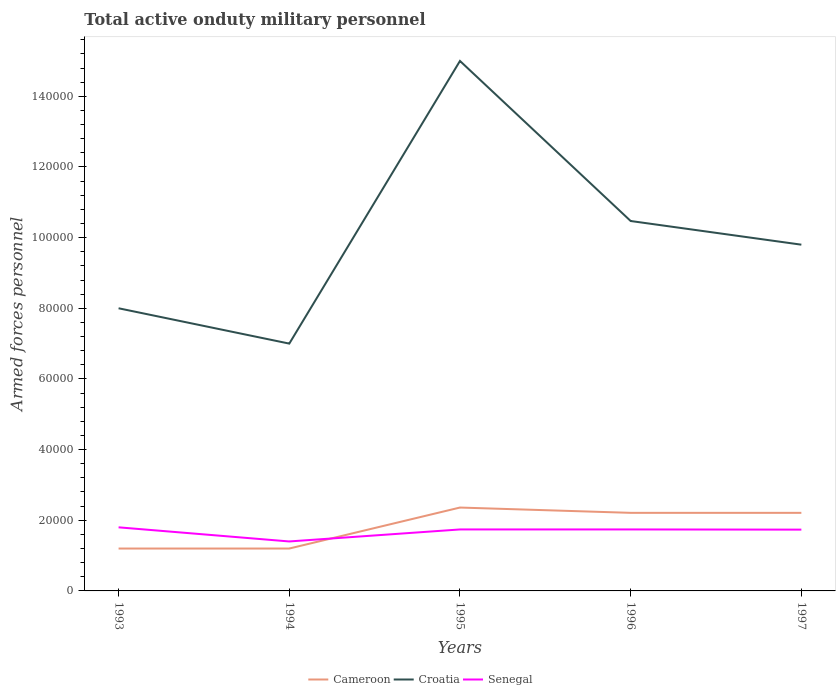How many different coloured lines are there?
Make the answer very short. 3. What is the total number of armed forces personnel in Senegal in the graph?
Provide a short and direct response. 600. What is the difference between the highest and the lowest number of armed forces personnel in Cameroon?
Keep it short and to the point. 3. How many lines are there?
Make the answer very short. 3. What is the difference between two consecutive major ticks on the Y-axis?
Offer a very short reply. 2.00e+04. Does the graph contain any zero values?
Keep it short and to the point. No. Does the graph contain grids?
Your answer should be very brief. No. How are the legend labels stacked?
Provide a short and direct response. Horizontal. What is the title of the graph?
Give a very brief answer. Total active onduty military personnel. What is the label or title of the Y-axis?
Provide a short and direct response. Armed forces personnel. What is the Armed forces personnel in Cameroon in 1993?
Ensure brevity in your answer.  1.20e+04. What is the Armed forces personnel of Senegal in 1993?
Give a very brief answer. 1.80e+04. What is the Armed forces personnel of Cameroon in 1994?
Offer a very short reply. 1.20e+04. What is the Armed forces personnel in Croatia in 1994?
Provide a succinct answer. 7.00e+04. What is the Armed forces personnel of Senegal in 1994?
Your answer should be compact. 1.40e+04. What is the Armed forces personnel of Cameroon in 1995?
Give a very brief answer. 2.36e+04. What is the Armed forces personnel of Senegal in 1995?
Offer a terse response. 1.74e+04. What is the Armed forces personnel of Cameroon in 1996?
Keep it short and to the point. 2.21e+04. What is the Armed forces personnel of Croatia in 1996?
Your answer should be very brief. 1.05e+05. What is the Armed forces personnel of Senegal in 1996?
Your response must be concise. 1.74e+04. What is the Armed forces personnel of Cameroon in 1997?
Provide a short and direct response. 2.21e+04. What is the Armed forces personnel in Croatia in 1997?
Make the answer very short. 9.80e+04. What is the Armed forces personnel of Senegal in 1997?
Offer a very short reply. 1.74e+04. Across all years, what is the maximum Armed forces personnel of Cameroon?
Ensure brevity in your answer.  2.36e+04. Across all years, what is the maximum Armed forces personnel of Croatia?
Your response must be concise. 1.50e+05. Across all years, what is the maximum Armed forces personnel of Senegal?
Your answer should be compact. 1.80e+04. Across all years, what is the minimum Armed forces personnel of Cameroon?
Your answer should be compact. 1.20e+04. Across all years, what is the minimum Armed forces personnel of Croatia?
Your answer should be very brief. 7.00e+04. Across all years, what is the minimum Armed forces personnel of Senegal?
Give a very brief answer. 1.40e+04. What is the total Armed forces personnel in Cameroon in the graph?
Your response must be concise. 9.18e+04. What is the total Armed forces personnel of Croatia in the graph?
Offer a very short reply. 5.03e+05. What is the total Armed forces personnel in Senegal in the graph?
Provide a succinct answer. 8.42e+04. What is the difference between the Armed forces personnel of Cameroon in 1993 and that in 1994?
Ensure brevity in your answer.  0. What is the difference between the Armed forces personnel in Croatia in 1993 and that in 1994?
Give a very brief answer. 10000. What is the difference between the Armed forces personnel in Senegal in 1993 and that in 1994?
Provide a succinct answer. 4000. What is the difference between the Armed forces personnel of Cameroon in 1993 and that in 1995?
Make the answer very short. -1.16e+04. What is the difference between the Armed forces personnel of Croatia in 1993 and that in 1995?
Keep it short and to the point. -7.00e+04. What is the difference between the Armed forces personnel in Senegal in 1993 and that in 1995?
Provide a succinct answer. 600. What is the difference between the Armed forces personnel of Cameroon in 1993 and that in 1996?
Provide a short and direct response. -1.01e+04. What is the difference between the Armed forces personnel in Croatia in 1993 and that in 1996?
Make the answer very short. -2.47e+04. What is the difference between the Armed forces personnel in Senegal in 1993 and that in 1996?
Your response must be concise. 600. What is the difference between the Armed forces personnel of Cameroon in 1993 and that in 1997?
Your response must be concise. -1.01e+04. What is the difference between the Armed forces personnel in Croatia in 1993 and that in 1997?
Keep it short and to the point. -1.80e+04. What is the difference between the Armed forces personnel in Senegal in 1993 and that in 1997?
Provide a succinct answer. 650. What is the difference between the Armed forces personnel in Cameroon in 1994 and that in 1995?
Provide a short and direct response. -1.16e+04. What is the difference between the Armed forces personnel of Croatia in 1994 and that in 1995?
Give a very brief answer. -8.00e+04. What is the difference between the Armed forces personnel in Senegal in 1994 and that in 1995?
Offer a very short reply. -3400. What is the difference between the Armed forces personnel of Cameroon in 1994 and that in 1996?
Give a very brief answer. -1.01e+04. What is the difference between the Armed forces personnel in Croatia in 1994 and that in 1996?
Your response must be concise. -3.47e+04. What is the difference between the Armed forces personnel of Senegal in 1994 and that in 1996?
Your response must be concise. -3400. What is the difference between the Armed forces personnel of Cameroon in 1994 and that in 1997?
Your response must be concise. -1.01e+04. What is the difference between the Armed forces personnel of Croatia in 1994 and that in 1997?
Your response must be concise. -2.80e+04. What is the difference between the Armed forces personnel of Senegal in 1994 and that in 1997?
Your answer should be compact. -3350. What is the difference between the Armed forces personnel of Cameroon in 1995 and that in 1996?
Provide a succinct answer. 1500. What is the difference between the Armed forces personnel of Croatia in 1995 and that in 1996?
Offer a very short reply. 4.53e+04. What is the difference between the Armed forces personnel in Cameroon in 1995 and that in 1997?
Give a very brief answer. 1500. What is the difference between the Armed forces personnel of Croatia in 1995 and that in 1997?
Offer a terse response. 5.20e+04. What is the difference between the Armed forces personnel of Cameroon in 1996 and that in 1997?
Provide a short and direct response. 0. What is the difference between the Armed forces personnel in Croatia in 1996 and that in 1997?
Your answer should be very brief. 6700. What is the difference between the Armed forces personnel of Cameroon in 1993 and the Armed forces personnel of Croatia in 1994?
Offer a terse response. -5.80e+04. What is the difference between the Armed forces personnel of Cameroon in 1993 and the Armed forces personnel of Senegal in 1994?
Offer a terse response. -2000. What is the difference between the Armed forces personnel in Croatia in 1993 and the Armed forces personnel in Senegal in 1994?
Give a very brief answer. 6.60e+04. What is the difference between the Armed forces personnel in Cameroon in 1993 and the Armed forces personnel in Croatia in 1995?
Give a very brief answer. -1.38e+05. What is the difference between the Armed forces personnel of Cameroon in 1993 and the Armed forces personnel of Senegal in 1995?
Ensure brevity in your answer.  -5400. What is the difference between the Armed forces personnel of Croatia in 1993 and the Armed forces personnel of Senegal in 1995?
Provide a short and direct response. 6.26e+04. What is the difference between the Armed forces personnel of Cameroon in 1993 and the Armed forces personnel of Croatia in 1996?
Offer a terse response. -9.27e+04. What is the difference between the Armed forces personnel in Cameroon in 1993 and the Armed forces personnel in Senegal in 1996?
Your response must be concise. -5400. What is the difference between the Armed forces personnel of Croatia in 1993 and the Armed forces personnel of Senegal in 1996?
Offer a very short reply. 6.26e+04. What is the difference between the Armed forces personnel in Cameroon in 1993 and the Armed forces personnel in Croatia in 1997?
Give a very brief answer. -8.60e+04. What is the difference between the Armed forces personnel in Cameroon in 1993 and the Armed forces personnel in Senegal in 1997?
Provide a succinct answer. -5350. What is the difference between the Armed forces personnel in Croatia in 1993 and the Armed forces personnel in Senegal in 1997?
Give a very brief answer. 6.26e+04. What is the difference between the Armed forces personnel of Cameroon in 1994 and the Armed forces personnel of Croatia in 1995?
Your response must be concise. -1.38e+05. What is the difference between the Armed forces personnel of Cameroon in 1994 and the Armed forces personnel of Senegal in 1995?
Your answer should be compact. -5400. What is the difference between the Armed forces personnel in Croatia in 1994 and the Armed forces personnel in Senegal in 1995?
Ensure brevity in your answer.  5.26e+04. What is the difference between the Armed forces personnel of Cameroon in 1994 and the Armed forces personnel of Croatia in 1996?
Ensure brevity in your answer.  -9.27e+04. What is the difference between the Armed forces personnel in Cameroon in 1994 and the Armed forces personnel in Senegal in 1996?
Keep it short and to the point. -5400. What is the difference between the Armed forces personnel in Croatia in 1994 and the Armed forces personnel in Senegal in 1996?
Offer a terse response. 5.26e+04. What is the difference between the Armed forces personnel in Cameroon in 1994 and the Armed forces personnel in Croatia in 1997?
Give a very brief answer. -8.60e+04. What is the difference between the Armed forces personnel in Cameroon in 1994 and the Armed forces personnel in Senegal in 1997?
Keep it short and to the point. -5350. What is the difference between the Armed forces personnel of Croatia in 1994 and the Armed forces personnel of Senegal in 1997?
Offer a very short reply. 5.26e+04. What is the difference between the Armed forces personnel of Cameroon in 1995 and the Armed forces personnel of Croatia in 1996?
Ensure brevity in your answer.  -8.11e+04. What is the difference between the Armed forces personnel in Cameroon in 1995 and the Armed forces personnel in Senegal in 1996?
Ensure brevity in your answer.  6200. What is the difference between the Armed forces personnel in Croatia in 1995 and the Armed forces personnel in Senegal in 1996?
Offer a very short reply. 1.33e+05. What is the difference between the Armed forces personnel of Cameroon in 1995 and the Armed forces personnel of Croatia in 1997?
Make the answer very short. -7.44e+04. What is the difference between the Armed forces personnel in Cameroon in 1995 and the Armed forces personnel in Senegal in 1997?
Give a very brief answer. 6250. What is the difference between the Armed forces personnel of Croatia in 1995 and the Armed forces personnel of Senegal in 1997?
Offer a very short reply. 1.33e+05. What is the difference between the Armed forces personnel in Cameroon in 1996 and the Armed forces personnel in Croatia in 1997?
Keep it short and to the point. -7.59e+04. What is the difference between the Armed forces personnel in Cameroon in 1996 and the Armed forces personnel in Senegal in 1997?
Your response must be concise. 4750. What is the difference between the Armed forces personnel of Croatia in 1996 and the Armed forces personnel of Senegal in 1997?
Keep it short and to the point. 8.74e+04. What is the average Armed forces personnel of Cameroon per year?
Provide a succinct answer. 1.84e+04. What is the average Armed forces personnel of Croatia per year?
Your response must be concise. 1.01e+05. What is the average Armed forces personnel of Senegal per year?
Your answer should be very brief. 1.68e+04. In the year 1993, what is the difference between the Armed forces personnel of Cameroon and Armed forces personnel of Croatia?
Your answer should be very brief. -6.80e+04. In the year 1993, what is the difference between the Armed forces personnel in Cameroon and Armed forces personnel in Senegal?
Offer a terse response. -6000. In the year 1993, what is the difference between the Armed forces personnel in Croatia and Armed forces personnel in Senegal?
Offer a terse response. 6.20e+04. In the year 1994, what is the difference between the Armed forces personnel of Cameroon and Armed forces personnel of Croatia?
Provide a succinct answer. -5.80e+04. In the year 1994, what is the difference between the Armed forces personnel in Cameroon and Armed forces personnel in Senegal?
Provide a succinct answer. -2000. In the year 1994, what is the difference between the Armed forces personnel of Croatia and Armed forces personnel of Senegal?
Your answer should be compact. 5.60e+04. In the year 1995, what is the difference between the Armed forces personnel in Cameroon and Armed forces personnel in Croatia?
Offer a very short reply. -1.26e+05. In the year 1995, what is the difference between the Armed forces personnel of Cameroon and Armed forces personnel of Senegal?
Your answer should be compact. 6200. In the year 1995, what is the difference between the Armed forces personnel in Croatia and Armed forces personnel in Senegal?
Your response must be concise. 1.33e+05. In the year 1996, what is the difference between the Armed forces personnel of Cameroon and Armed forces personnel of Croatia?
Your answer should be compact. -8.26e+04. In the year 1996, what is the difference between the Armed forces personnel of Cameroon and Armed forces personnel of Senegal?
Your response must be concise. 4700. In the year 1996, what is the difference between the Armed forces personnel in Croatia and Armed forces personnel in Senegal?
Ensure brevity in your answer.  8.73e+04. In the year 1997, what is the difference between the Armed forces personnel of Cameroon and Armed forces personnel of Croatia?
Give a very brief answer. -7.59e+04. In the year 1997, what is the difference between the Armed forces personnel in Cameroon and Armed forces personnel in Senegal?
Keep it short and to the point. 4750. In the year 1997, what is the difference between the Armed forces personnel in Croatia and Armed forces personnel in Senegal?
Your answer should be compact. 8.06e+04. What is the ratio of the Armed forces personnel in Cameroon in 1993 to that in 1994?
Provide a short and direct response. 1. What is the ratio of the Armed forces personnel in Croatia in 1993 to that in 1994?
Ensure brevity in your answer.  1.14. What is the ratio of the Armed forces personnel in Cameroon in 1993 to that in 1995?
Your response must be concise. 0.51. What is the ratio of the Armed forces personnel in Croatia in 1993 to that in 1995?
Offer a terse response. 0.53. What is the ratio of the Armed forces personnel in Senegal in 1993 to that in 1995?
Your answer should be compact. 1.03. What is the ratio of the Armed forces personnel in Cameroon in 1993 to that in 1996?
Your answer should be compact. 0.54. What is the ratio of the Armed forces personnel of Croatia in 1993 to that in 1996?
Give a very brief answer. 0.76. What is the ratio of the Armed forces personnel of Senegal in 1993 to that in 1996?
Offer a very short reply. 1.03. What is the ratio of the Armed forces personnel of Cameroon in 1993 to that in 1997?
Offer a very short reply. 0.54. What is the ratio of the Armed forces personnel in Croatia in 1993 to that in 1997?
Make the answer very short. 0.82. What is the ratio of the Armed forces personnel in Senegal in 1993 to that in 1997?
Your answer should be very brief. 1.04. What is the ratio of the Armed forces personnel in Cameroon in 1994 to that in 1995?
Your answer should be compact. 0.51. What is the ratio of the Armed forces personnel of Croatia in 1994 to that in 1995?
Your response must be concise. 0.47. What is the ratio of the Armed forces personnel of Senegal in 1994 to that in 1995?
Offer a terse response. 0.8. What is the ratio of the Armed forces personnel in Cameroon in 1994 to that in 1996?
Make the answer very short. 0.54. What is the ratio of the Armed forces personnel in Croatia in 1994 to that in 1996?
Offer a terse response. 0.67. What is the ratio of the Armed forces personnel of Senegal in 1994 to that in 1996?
Your answer should be very brief. 0.8. What is the ratio of the Armed forces personnel in Cameroon in 1994 to that in 1997?
Ensure brevity in your answer.  0.54. What is the ratio of the Armed forces personnel of Croatia in 1994 to that in 1997?
Provide a short and direct response. 0.71. What is the ratio of the Armed forces personnel in Senegal in 1994 to that in 1997?
Give a very brief answer. 0.81. What is the ratio of the Armed forces personnel of Cameroon in 1995 to that in 1996?
Give a very brief answer. 1.07. What is the ratio of the Armed forces personnel of Croatia in 1995 to that in 1996?
Your answer should be very brief. 1.43. What is the ratio of the Armed forces personnel in Cameroon in 1995 to that in 1997?
Give a very brief answer. 1.07. What is the ratio of the Armed forces personnel in Croatia in 1995 to that in 1997?
Your answer should be compact. 1.53. What is the ratio of the Armed forces personnel in Senegal in 1995 to that in 1997?
Offer a very short reply. 1. What is the ratio of the Armed forces personnel of Croatia in 1996 to that in 1997?
Provide a succinct answer. 1.07. What is the ratio of the Armed forces personnel of Senegal in 1996 to that in 1997?
Offer a terse response. 1. What is the difference between the highest and the second highest Armed forces personnel of Cameroon?
Give a very brief answer. 1500. What is the difference between the highest and the second highest Armed forces personnel of Croatia?
Offer a terse response. 4.53e+04. What is the difference between the highest and the second highest Armed forces personnel of Senegal?
Offer a very short reply. 600. What is the difference between the highest and the lowest Armed forces personnel in Cameroon?
Give a very brief answer. 1.16e+04. What is the difference between the highest and the lowest Armed forces personnel in Croatia?
Give a very brief answer. 8.00e+04. What is the difference between the highest and the lowest Armed forces personnel in Senegal?
Your answer should be very brief. 4000. 